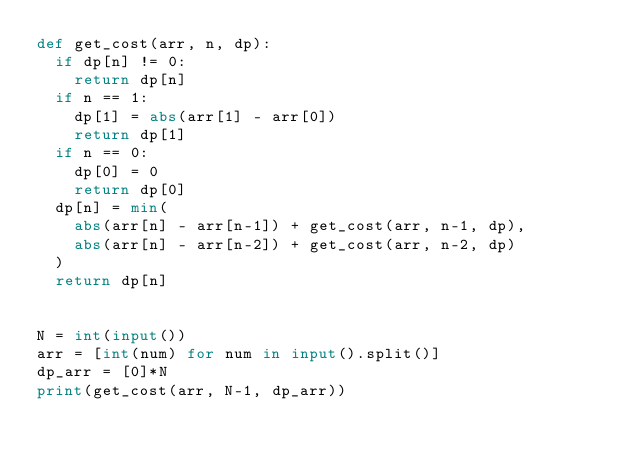<code> <loc_0><loc_0><loc_500><loc_500><_Python_>def get_cost(arr, n, dp):
  if dp[n] != 0:
    return dp[n]
  if n == 1:
    dp[1] = abs(arr[1] - arr[0])
    return dp[1]
  if n == 0:
    dp[0] = 0
    return dp[0]
  dp[n] = min(
    abs(arr[n] - arr[n-1]) + get_cost(arr, n-1, dp),
    abs(arr[n] - arr[n-2]) + get_cost(arr, n-2, dp)
  )
  return dp[n]


N = int(input())
arr = [int(num) for num in input().split()]
dp_arr = [0]*N
print(get_cost(arr, N-1, dp_arr))
</code> 